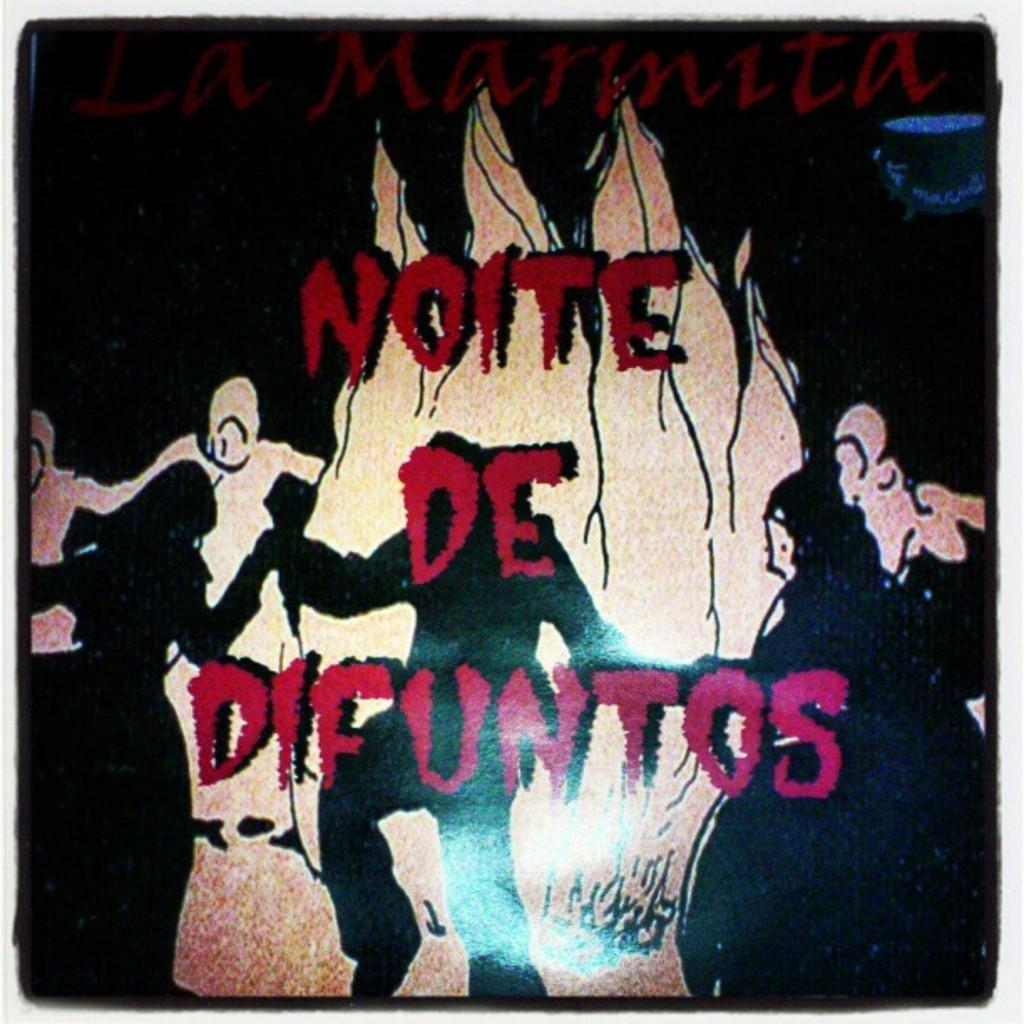What is featured in the picture? There is a poster in the picture. What is depicted on the poster? The poster contains an image of people standing around a fire. Is there any text or writing on the poster? Yes, there is text or writing on the poster. What type of pickle is being used to improve the acoustics of the room in the image? There is no pickle present in the image, nor is there any mention of improving acoustics. Additionally, there is no goose in the image. 